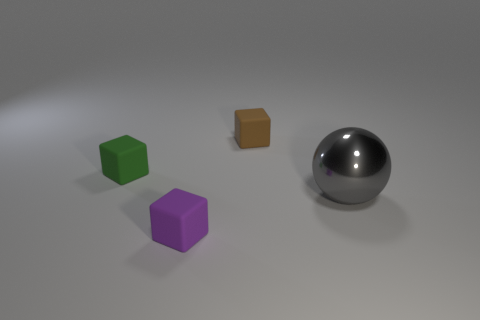Add 4 big red metal cylinders. How many objects exist? 8 Subtract all cubes. How many objects are left? 1 Subtract all big metal spheres. Subtract all big gray metal things. How many objects are left? 2 Add 4 small green cubes. How many small green cubes are left? 5 Add 4 small brown matte things. How many small brown matte things exist? 5 Subtract 0 red cubes. How many objects are left? 4 